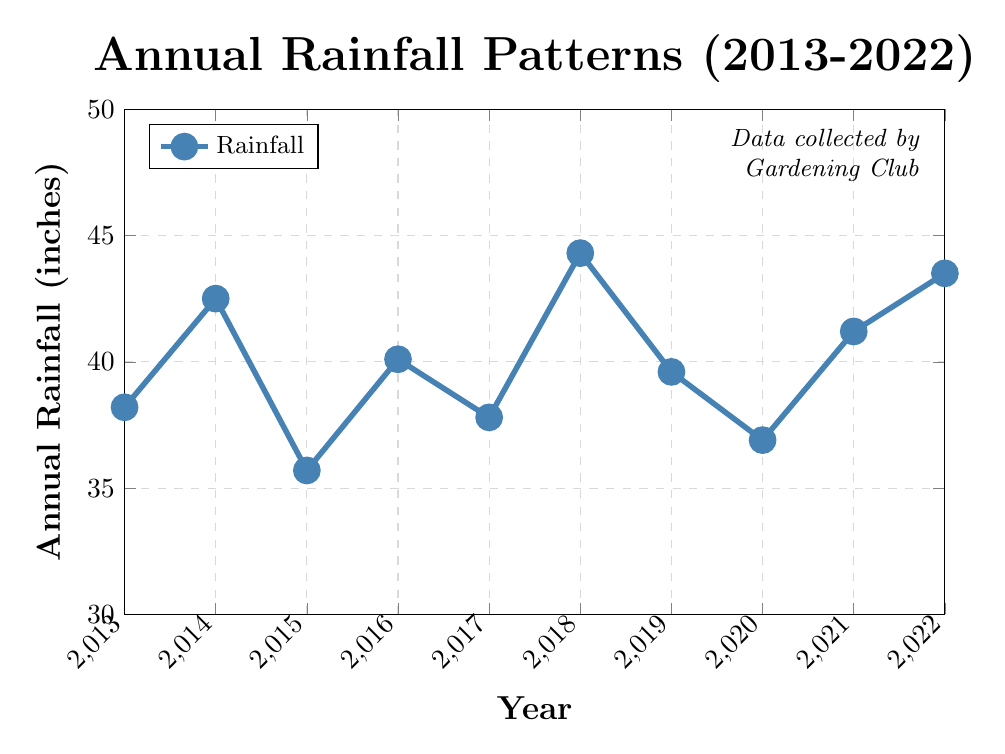Which year had the highest annual rainfall? The graph shows the annual rainfall for each year between 2013 and 2022. The highest point on the line corresponds to the year with the highest rainfall. The highest point is at 2018 with 44.3 inches.
Answer: 2018 Which year had the lowest annual rainfall? To determine this, look for the lowest point on the graph. The lowest point corresponds to 2015 with 35.7 inches of rainfall.
Answer: 2015 By how many inches did the rainfall increase from 2013 to 2014? The difference in annual rainfall between 2014 and 2013 can be calculated by subtracting the 2013 value from the 2014 value: 42.5 - 38.2 = 4.3 inches.
Answer: 4.3 inches What is the average annual rainfall over the 10 years? To find the average, add all the annual rainfall totals and divide by 10: (38.2 + 42.5 + 35.7 + 40.1 + 37.8 + 44.3 + 39.6 + 36.9 + 41.2 + 43.5) / 10 = 40.98 inches.
Answer: 40.98 inches Is the annual rainfall trend increasing, decreasing, or stable over the 10 years? By observing the overall direction of the line from 2013 to 2022, there are fluctuations but no clear upwards or downwards trend, so it is roughly stable.
Answer: Stable Which two consecutive years had the largest increase in rainfall? By comparing the difference between consecutive years, the largest increase is from 2017 to 2018, where rainfall increased from 37.8 inches to 44.3 inches, a difference of 6.5 inches.
Answer: 2017 to 2018 What was the total rainfall over the past 10 years? Sum the annual rainfall for each year from 2013 to 2022: 38.2 + 42.5 + 35.7 + 40.1 + 37.8 + 44.3 + 39.6 + 36.9 + 41.2 + 43.5 = 399.8 inches.
Answer: 399.8 inches By how many inches did the rainfall in 2022 exceed that in 2019? Subtract the annual rainfall in 2019 from that in 2022: 43.5 - 39.6 = 3.9 inches.
Answer: 3.9 inches Which year had slightly lower rainfall than 2022 but higher than 2019? Examine the years between 2019 and 2022, we find that 2021 had 41.2 inches, which is slightly lower than 2022 but higher than 2019.
Answer: 2021 What color is used to represent the rainfall line in the plot? The line representing the rainfall is colored blue.
Answer: Blue 